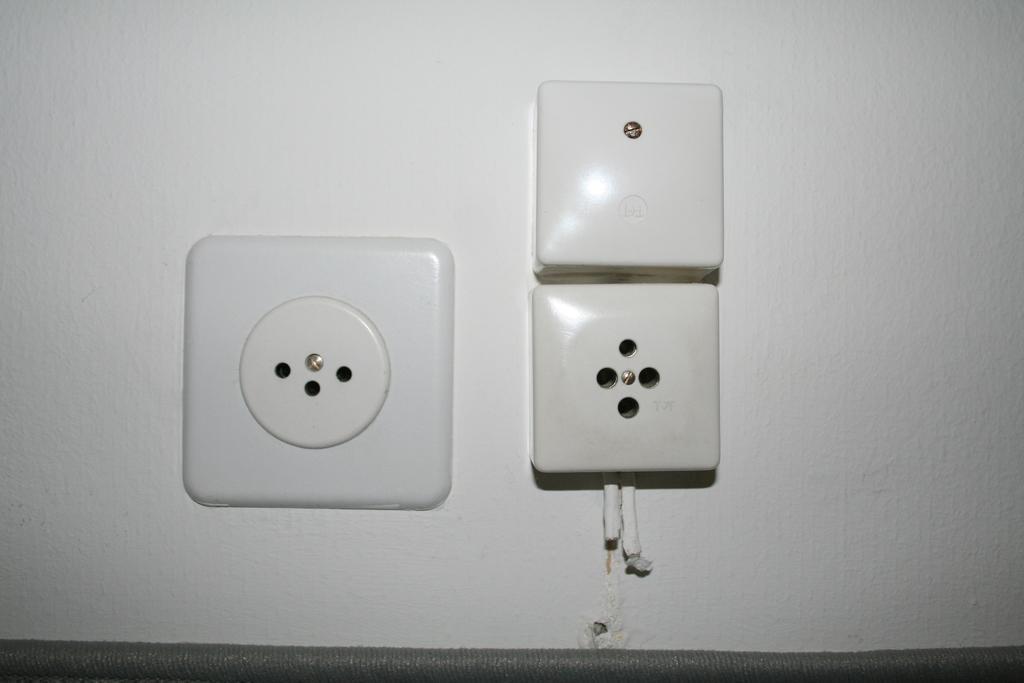How would you summarize this image in a sentence or two? Here we can see sockets on white wall. 